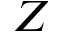Convert formula to latex. <formula><loc_0><loc_0><loc_500><loc_500>Z</formula> 